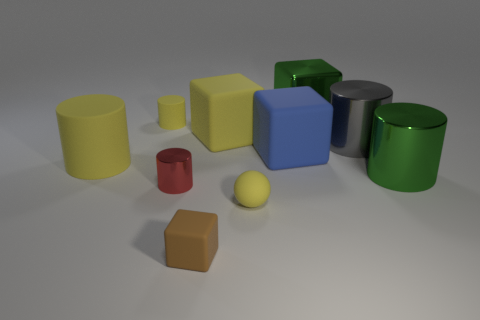There is a small cylinder that is the same color as the ball; what is its material?
Offer a terse response. Rubber. What shape is the small object that is the same color as the tiny sphere?
Keep it short and to the point. Cylinder. What size is the rubber block that is both left of the blue rubber block and to the right of the tiny block?
Provide a short and direct response. Large. Are there any big metal cylinders behind the big green block?
Offer a very short reply. No. What number of things are either big yellow things behind the blue object or small yellow rubber things?
Offer a very short reply. 3. What number of gray shiny cylinders are left of the small yellow matte object that is on the left side of the yellow sphere?
Your response must be concise. 0. Is the number of tiny red shiny cylinders that are behind the big green shiny cylinder less than the number of tiny yellow objects in front of the big yellow cube?
Make the answer very short. Yes. What is the shape of the object in front of the matte ball that is in front of the red object?
Make the answer very short. Cube. What number of other things are the same material as the green cylinder?
Your answer should be very brief. 3. Is the number of large yellow matte cylinders greater than the number of large red rubber cylinders?
Your answer should be compact. Yes. 